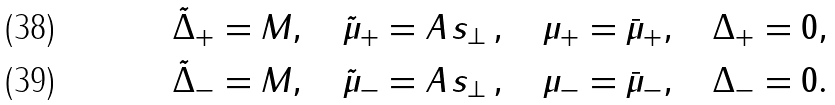Convert formula to latex. <formula><loc_0><loc_0><loc_500><loc_500>& \tilde { \Delta } _ { + } = M , \quad \tilde { \mu } _ { + } = A \, s _ { \perp } \, , \quad \mu _ { + } = \bar { \mu } _ { + } , \quad \Delta _ { + } = 0 , \\ & \tilde { \Delta } _ { - } = M , \quad \tilde { \mu } _ { - } = A \, s _ { \perp } \, , \quad \mu _ { - } = \bar { \mu } _ { - } , \quad \Delta _ { - } = 0 .</formula> 